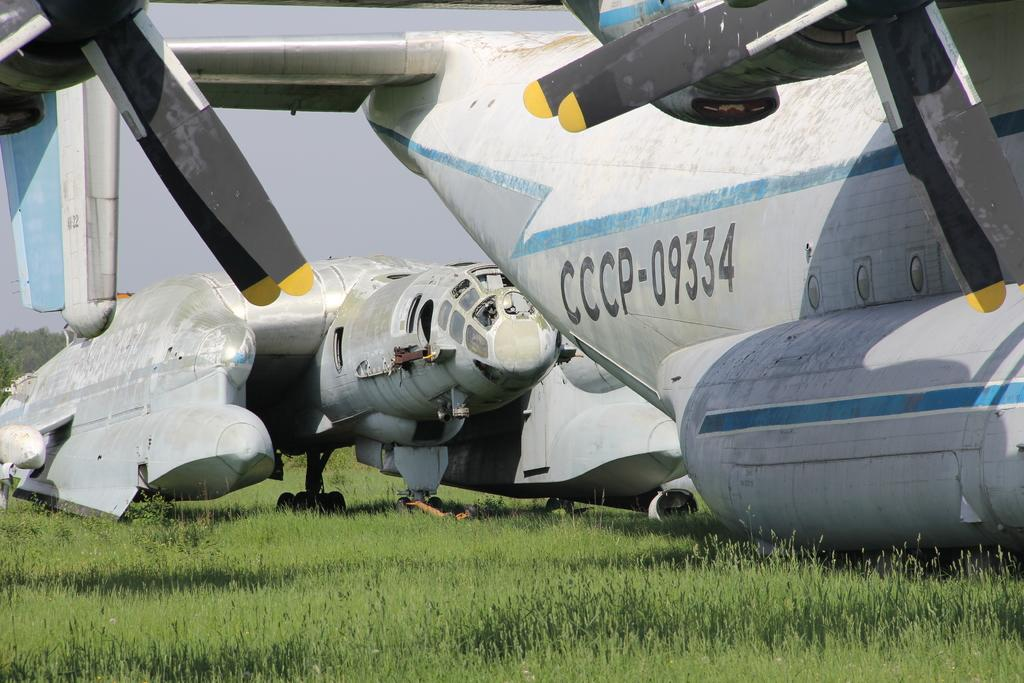<image>
Offer a succinct explanation of the picture presented. Airplane CCCP-09334 that has black propellers sits on the grass. 